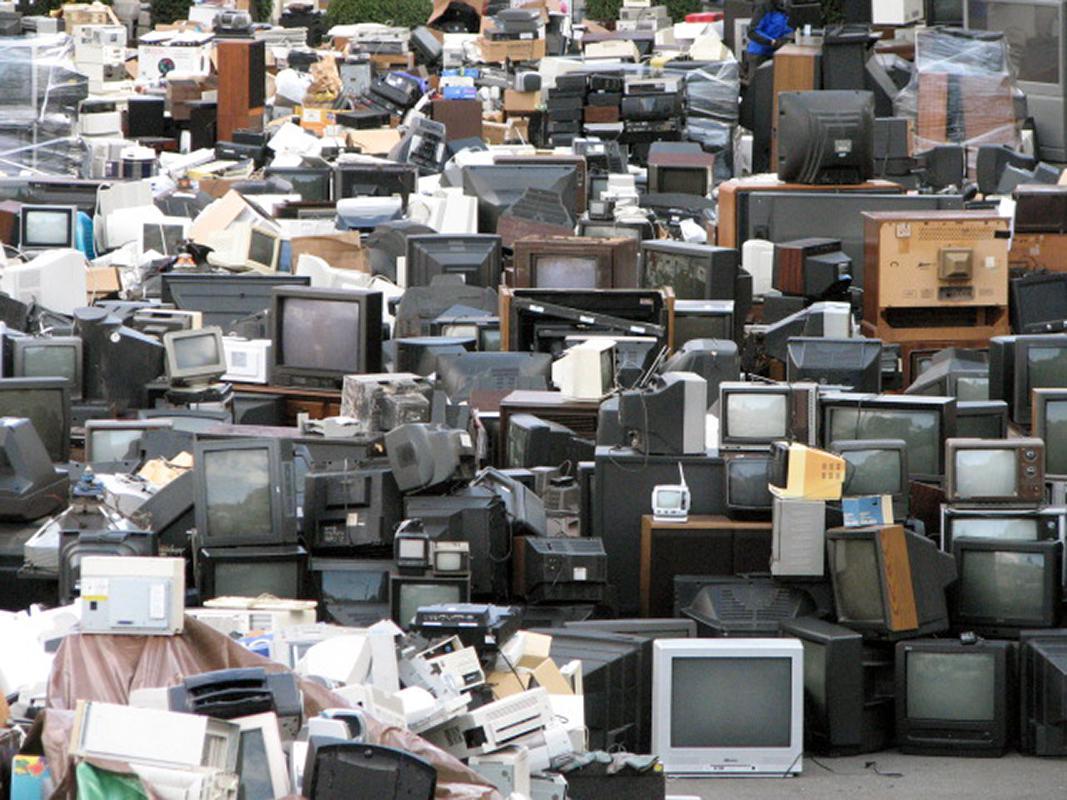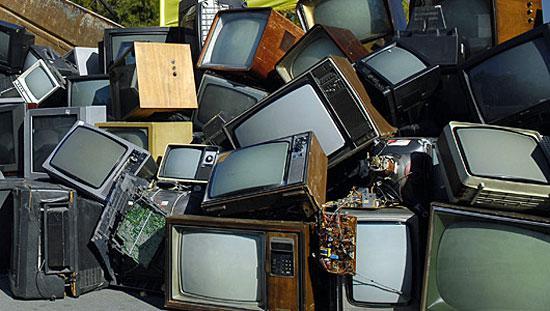The first image is the image on the left, the second image is the image on the right. For the images displayed, is the sentence "The televisions in the image on the right are all turned on." factually correct? Answer yes or no. No. The first image is the image on the left, the second image is the image on the right. For the images shown, is this caption "All the TVs stacked in the right image have different scenes playing on the screens." true? Answer yes or no. No. 